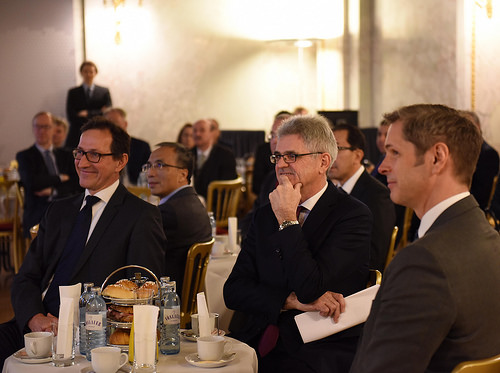<image>
Can you confirm if the man is to the left of the man? Yes. From this viewpoint, the man is positioned to the left side relative to the man. Where is the coffee cup in relation to the man? Is it next to the man? No. The coffee cup is not positioned next to the man. They are located in different areas of the scene. Where is the tie in relation to the bottle? Is it next to the bottle? No. The tie is not positioned next to the bottle. They are located in different areas of the scene. 